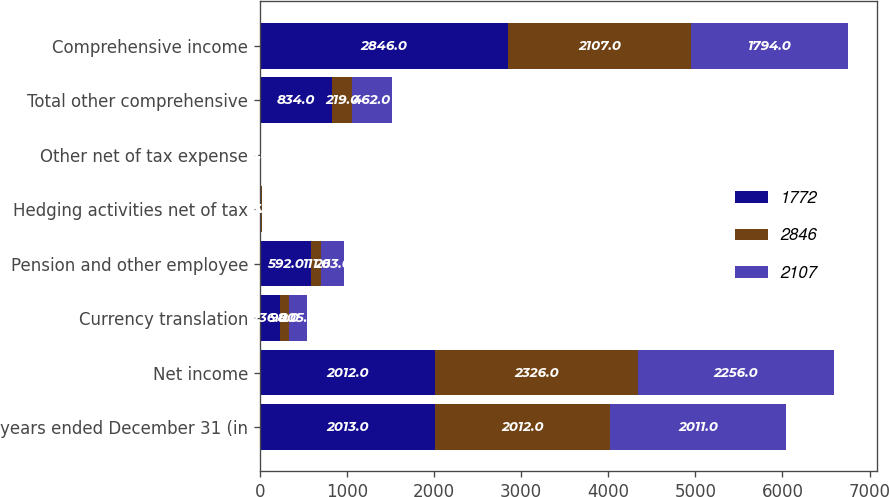<chart> <loc_0><loc_0><loc_500><loc_500><stacked_bar_chart><ecel><fcel>years ended December 31 (in<fcel>Net income<fcel>Currency translation<fcel>Pension and other employee<fcel>Hedging activities net of tax<fcel>Other net of tax expense<fcel>Total other comprehensive<fcel>Comprehensive income<nl><fcel>1772<fcel>2013<fcel>2012<fcel>236<fcel>592<fcel>15<fcel>9<fcel>834<fcel>2846<nl><fcel>2846<fcel>2012<fcel>2326<fcel>98<fcel>111<fcel>7<fcel>3<fcel>219<fcel>2107<nl><fcel>2107<fcel>2011<fcel>2256<fcel>205<fcel>263<fcel>5<fcel>1<fcel>462<fcel>1794<nl></chart> 